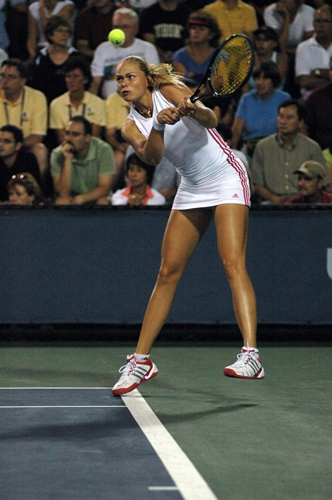Describe the objects in this image and their specific colors. I can see people in gray, brown, lightgray, and maroon tones, people in gray and black tones, people in gray, black, and maroon tones, people in gray and black tones, and people in gray, tan, black, and maroon tones in this image. 